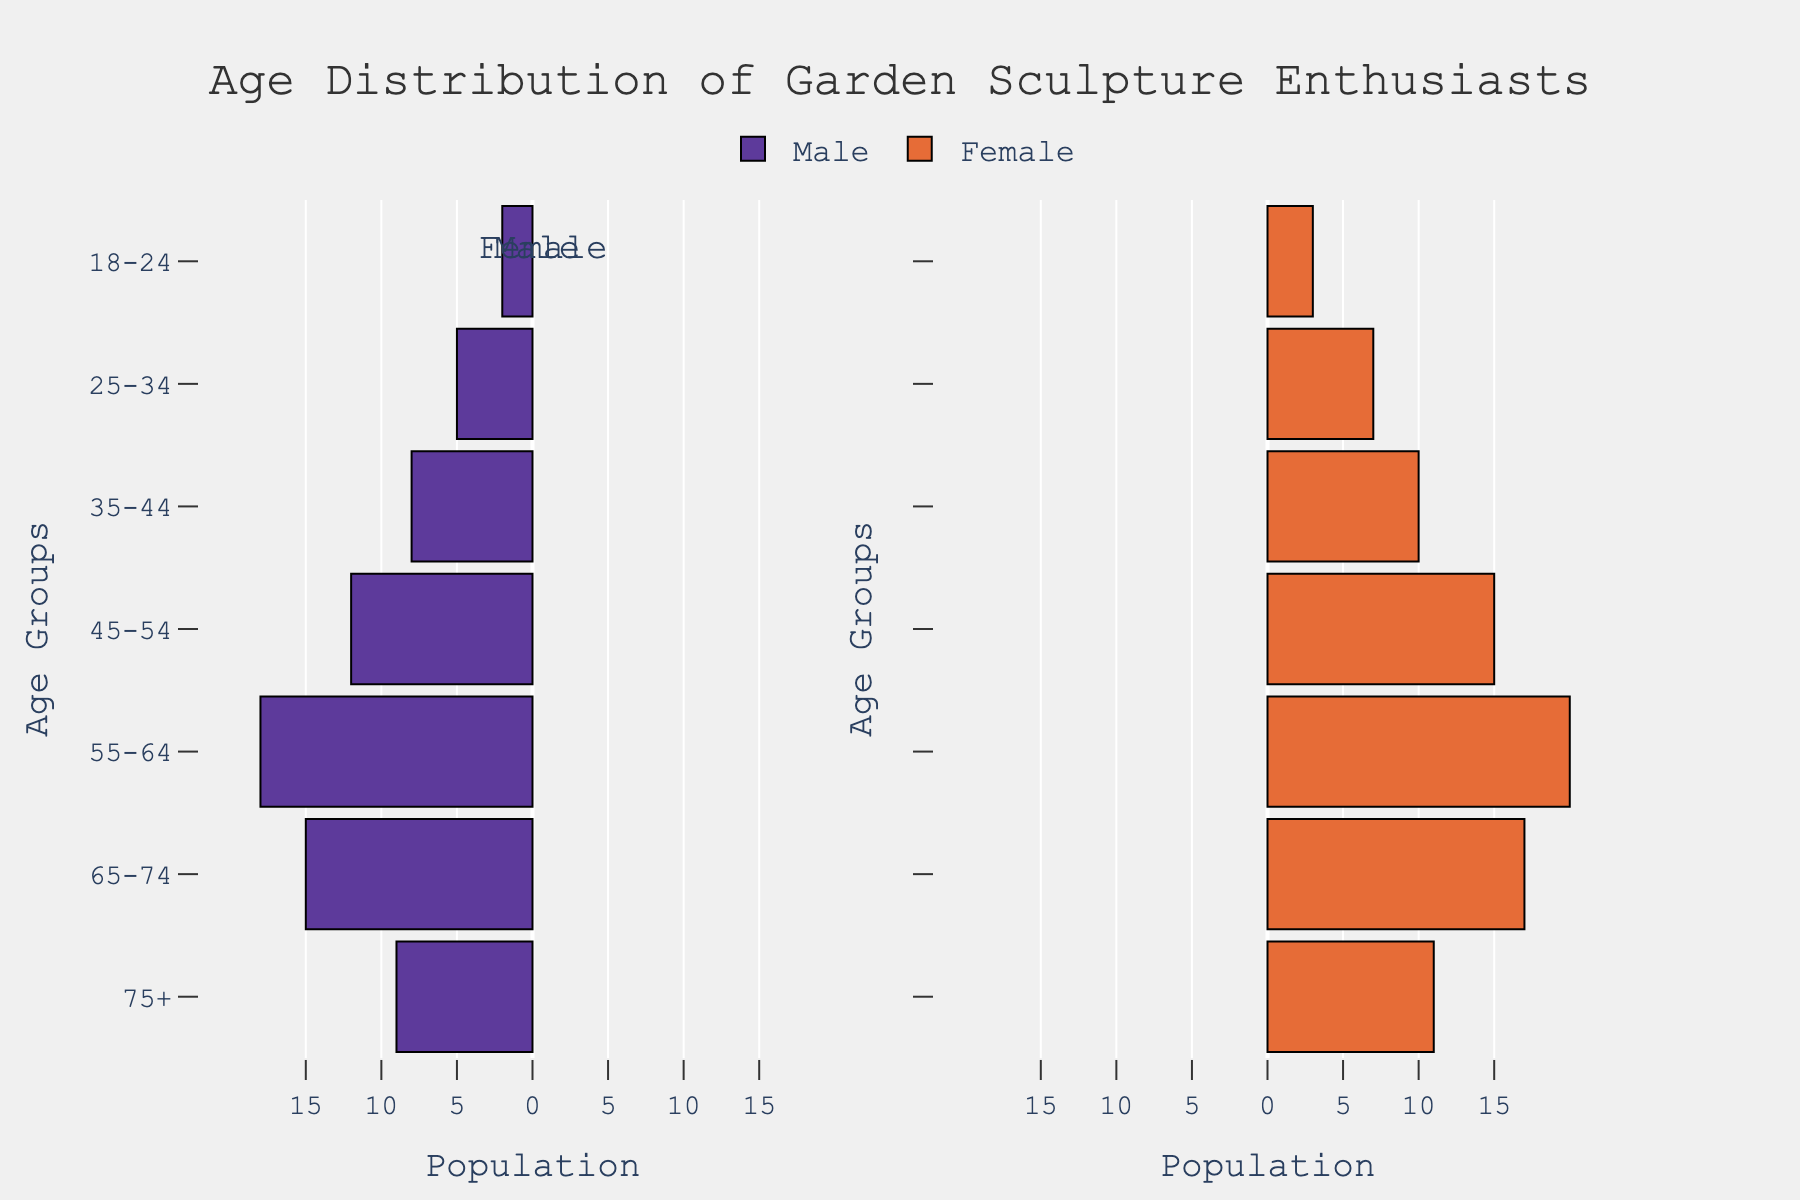What is the title of the figure? The title is located at the top center of the figure in large font and reads "Age Distribution of Garden Sculpture Enthusiasts."
Answer: Age Distribution of Garden Sculpture Enthusiasts What are the colors of the bars representing male and female enthusiasts? The figure uses two distinct colors; the male bars are purple and the female bars are orange.
Answer: Purple for male and orange for female In which age group is the number of female enthusiasts the highest? By looking at the bars representing female enthusiasts, we find that the age group 55-64 has the longest bar, indicating the highest number of female enthusiasts.
Answer: 55-64 What is the total number of enthusiasts aged 65-74? Add the number of male and female enthusiasts in the 65-74 age group: 15 males + 17 females = 32 enthusiasts.
Answer: 32 Which gender has more enthusiasts in the 25-34 age group? Compare the lengths of the bars for the 25-34 age group; the bar for female enthusiasts is longer than the bar for male enthusiasts, indicating more female enthusiasts.
Answer: Female What is the difference between the number of male and female enthusiasts in the 45-54 age group? Subtract the number of male enthusiasts from the number of female enthusiasts in this age group: 15 - 12 = 3.
Answer: 3 Are there more male or female enthusiasts in the oldest age group, 75+? By visually comparing the lengths of the bars for the 75+ age group, the female bar is slightly longer than the male bar.
Answer: Female What is the combined total of male and female enthusiasts in the 35-44 age group? Add the number of male enthusiasts (8) to the number of female enthusiasts (10) in the 35-44 age group: 8 + 10 = 18.
Answer: 18 Which age group has the fewest male enthusiasts? The age group with the smallest male bar is the 18-24 age group, indicating the fewest male enthusiasts.
Answer: 18-24 In which age group do male enthusiasts outnumber female enthusiasts? By comparing the male and female bars in each age group, male enthusiasts outnumber female enthusiasts only in the 65-74 age group (15 males vs. 17 females).
Answer: None 